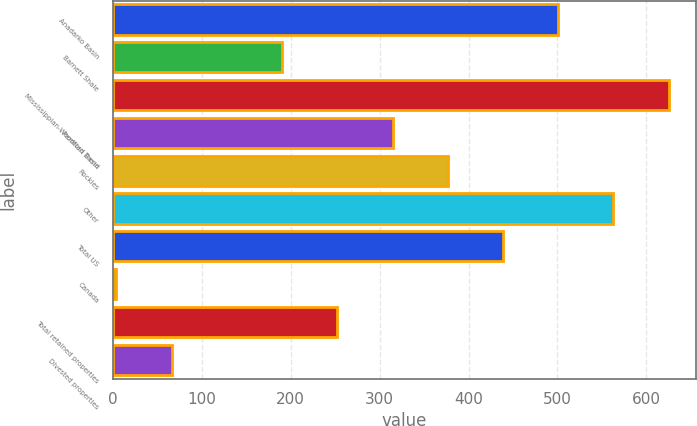Convert chart. <chart><loc_0><loc_0><loc_500><loc_500><bar_chart><fcel>Anadarko Basin<fcel>Barnett Shale<fcel>Mississippian-Woodford Trend<fcel>Permian Basin<fcel>Rockies<fcel>Other<fcel>Total US<fcel>Canada<fcel>Total retained properties<fcel>Divested properties<nl><fcel>500.8<fcel>190.3<fcel>625<fcel>314.5<fcel>376.6<fcel>562.9<fcel>438.7<fcel>4<fcel>252.4<fcel>66.1<nl></chart> 